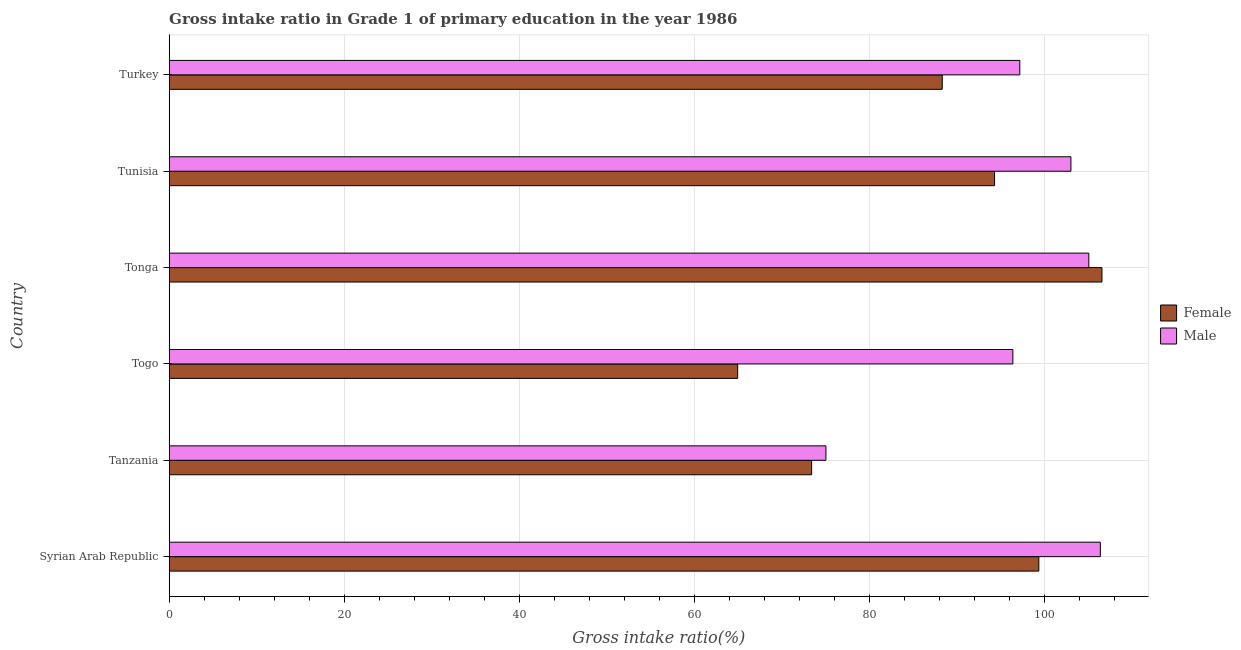How many different coloured bars are there?
Offer a terse response. 2. How many groups of bars are there?
Your answer should be compact. 6. Are the number of bars per tick equal to the number of legend labels?
Offer a very short reply. Yes. Are the number of bars on each tick of the Y-axis equal?
Provide a succinct answer. Yes. How many bars are there on the 6th tick from the bottom?
Offer a terse response. 2. What is the label of the 3rd group of bars from the top?
Keep it short and to the point. Tonga. What is the gross intake ratio(female) in Tunisia?
Keep it short and to the point. 94.3. Across all countries, what is the maximum gross intake ratio(female)?
Ensure brevity in your answer.  106.57. Across all countries, what is the minimum gross intake ratio(male)?
Ensure brevity in your answer.  75.04. In which country was the gross intake ratio(male) maximum?
Your answer should be compact. Syrian Arab Republic. In which country was the gross intake ratio(female) minimum?
Offer a very short reply. Togo. What is the total gross intake ratio(female) in the graph?
Make the answer very short. 526.92. What is the difference between the gross intake ratio(female) in Tonga and that in Tunisia?
Your answer should be very brief. 12.27. What is the difference between the gross intake ratio(female) in Tanzania and the gross intake ratio(male) in Tonga?
Provide a succinct answer. -31.67. What is the average gross intake ratio(male) per country?
Your answer should be very brief. 97.19. What is the difference between the gross intake ratio(female) and gross intake ratio(male) in Tunisia?
Offer a very short reply. -8.72. What is the ratio of the gross intake ratio(female) in Tonga to that in Turkey?
Make the answer very short. 1.21. Is the gross intake ratio(male) in Syrian Arab Republic less than that in Tanzania?
Your answer should be very brief. No. What is the difference between the highest and the second highest gross intake ratio(female)?
Provide a succinct answer. 7.21. What is the difference between the highest and the lowest gross intake ratio(male)?
Ensure brevity in your answer.  31.35. In how many countries, is the gross intake ratio(female) greater than the average gross intake ratio(female) taken over all countries?
Provide a short and direct response. 4. How many bars are there?
Make the answer very short. 12. Are all the bars in the graph horizontal?
Provide a succinct answer. Yes. How many countries are there in the graph?
Make the answer very short. 6. Does the graph contain any zero values?
Ensure brevity in your answer.  No. Does the graph contain grids?
Offer a very short reply. Yes. How are the legend labels stacked?
Your answer should be very brief. Vertical. What is the title of the graph?
Provide a succinct answer. Gross intake ratio in Grade 1 of primary education in the year 1986. What is the label or title of the X-axis?
Offer a terse response. Gross intake ratio(%). What is the Gross intake ratio(%) of Female in Syrian Arab Republic?
Ensure brevity in your answer.  99.36. What is the Gross intake ratio(%) of Male in Syrian Arab Republic?
Offer a very short reply. 106.39. What is the Gross intake ratio(%) in Female in Tanzania?
Your response must be concise. 73.4. What is the Gross intake ratio(%) in Male in Tanzania?
Make the answer very short. 75.04. What is the Gross intake ratio(%) of Female in Togo?
Your answer should be very brief. 64.95. What is the Gross intake ratio(%) of Male in Togo?
Keep it short and to the point. 96.4. What is the Gross intake ratio(%) in Female in Tonga?
Your response must be concise. 106.57. What is the Gross intake ratio(%) of Male in Tonga?
Keep it short and to the point. 105.08. What is the Gross intake ratio(%) of Female in Tunisia?
Make the answer very short. 94.3. What is the Gross intake ratio(%) in Male in Tunisia?
Ensure brevity in your answer.  103.03. What is the Gross intake ratio(%) of Female in Turkey?
Your response must be concise. 88.33. What is the Gross intake ratio(%) of Male in Turkey?
Your response must be concise. 97.19. Across all countries, what is the maximum Gross intake ratio(%) of Female?
Your answer should be compact. 106.57. Across all countries, what is the maximum Gross intake ratio(%) in Male?
Offer a very short reply. 106.39. Across all countries, what is the minimum Gross intake ratio(%) of Female?
Ensure brevity in your answer.  64.95. Across all countries, what is the minimum Gross intake ratio(%) in Male?
Provide a short and direct response. 75.04. What is the total Gross intake ratio(%) of Female in the graph?
Your answer should be very brief. 526.92. What is the total Gross intake ratio(%) of Male in the graph?
Keep it short and to the point. 583.12. What is the difference between the Gross intake ratio(%) of Female in Syrian Arab Republic and that in Tanzania?
Offer a terse response. 25.96. What is the difference between the Gross intake ratio(%) in Male in Syrian Arab Republic and that in Tanzania?
Offer a very short reply. 31.35. What is the difference between the Gross intake ratio(%) in Female in Syrian Arab Republic and that in Togo?
Offer a very short reply. 34.41. What is the difference between the Gross intake ratio(%) in Male in Syrian Arab Republic and that in Togo?
Ensure brevity in your answer.  9.99. What is the difference between the Gross intake ratio(%) in Female in Syrian Arab Republic and that in Tonga?
Offer a very short reply. -7.21. What is the difference between the Gross intake ratio(%) of Male in Syrian Arab Republic and that in Tonga?
Provide a short and direct response. 1.31. What is the difference between the Gross intake ratio(%) of Female in Syrian Arab Republic and that in Tunisia?
Give a very brief answer. 5.06. What is the difference between the Gross intake ratio(%) in Male in Syrian Arab Republic and that in Tunisia?
Ensure brevity in your answer.  3.36. What is the difference between the Gross intake ratio(%) in Female in Syrian Arab Republic and that in Turkey?
Provide a short and direct response. 11.04. What is the difference between the Gross intake ratio(%) of Male in Syrian Arab Republic and that in Turkey?
Your answer should be very brief. 9.2. What is the difference between the Gross intake ratio(%) in Female in Tanzania and that in Togo?
Ensure brevity in your answer.  8.45. What is the difference between the Gross intake ratio(%) of Male in Tanzania and that in Togo?
Keep it short and to the point. -21.36. What is the difference between the Gross intake ratio(%) in Female in Tanzania and that in Tonga?
Offer a terse response. -33.17. What is the difference between the Gross intake ratio(%) in Male in Tanzania and that in Tonga?
Give a very brief answer. -30.04. What is the difference between the Gross intake ratio(%) in Female in Tanzania and that in Tunisia?
Provide a succinct answer. -20.9. What is the difference between the Gross intake ratio(%) in Male in Tanzania and that in Tunisia?
Provide a succinct answer. -27.99. What is the difference between the Gross intake ratio(%) in Female in Tanzania and that in Turkey?
Your answer should be compact. -14.92. What is the difference between the Gross intake ratio(%) of Male in Tanzania and that in Turkey?
Give a very brief answer. -22.15. What is the difference between the Gross intake ratio(%) in Female in Togo and that in Tonga?
Offer a very short reply. -41.62. What is the difference between the Gross intake ratio(%) of Male in Togo and that in Tonga?
Ensure brevity in your answer.  -8.68. What is the difference between the Gross intake ratio(%) in Female in Togo and that in Tunisia?
Offer a terse response. -29.35. What is the difference between the Gross intake ratio(%) of Male in Togo and that in Tunisia?
Give a very brief answer. -6.63. What is the difference between the Gross intake ratio(%) in Female in Togo and that in Turkey?
Make the answer very short. -23.37. What is the difference between the Gross intake ratio(%) in Male in Togo and that in Turkey?
Your response must be concise. -0.79. What is the difference between the Gross intake ratio(%) in Female in Tonga and that in Tunisia?
Provide a succinct answer. 12.27. What is the difference between the Gross intake ratio(%) of Male in Tonga and that in Tunisia?
Give a very brief answer. 2.05. What is the difference between the Gross intake ratio(%) of Female in Tonga and that in Turkey?
Offer a terse response. 18.25. What is the difference between the Gross intake ratio(%) in Male in Tonga and that in Turkey?
Make the answer very short. 7.89. What is the difference between the Gross intake ratio(%) in Female in Tunisia and that in Turkey?
Make the answer very short. 5.98. What is the difference between the Gross intake ratio(%) of Male in Tunisia and that in Turkey?
Your answer should be very brief. 5.84. What is the difference between the Gross intake ratio(%) of Female in Syrian Arab Republic and the Gross intake ratio(%) of Male in Tanzania?
Make the answer very short. 24.33. What is the difference between the Gross intake ratio(%) of Female in Syrian Arab Republic and the Gross intake ratio(%) of Male in Togo?
Keep it short and to the point. 2.97. What is the difference between the Gross intake ratio(%) of Female in Syrian Arab Republic and the Gross intake ratio(%) of Male in Tonga?
Keep it short and to the point. -5.71. What is the difference between the Gross intake ratio(%) of Female in Syrian Arab Republic and the Gross intake ratio(%) of Male in Tunisia?
Keep it short and to the point. -3.67. What is the difference between the Gross intake ratio(%) in Female in Syrian Arab Republic and the Gross intake ratio(%) in Male in Turkey?
Offer a terse response. 2.18. What is the difference between the Gross intake ratio(%) in Female in Tanzania and the Gross intake ratio(%) in Male in Togo?
Offer a very short reply. -22.99. What is the difference between the Gross intake ratio(%) in Female in Tanzania and the Gross intake ratio(%) in Male in Tonga?
Offer a very short reply. -31.67. What is the difference between the Gross intake ratio(%) in Female in Tanzania and the Gross intake ratio(%) in Male in Tunisia?
Your answer should be very brief. -29.63. What is the difference between the Gross intake ratio(%) of Female in Tanzania and the Gross intake ratio(%) of Male in Turkey?
Your response must be concise. -23.78. What is the difference between the Gross intake ratio(%) of Female in Togo and the Gross intake ratio(%) of Male in Tonga?
Your answer should be very brief. -40.12. What is the difference between the Gross intake ratio(%) of Female in Togo and the Gross intake ratio(%) of Male in Tunisia?
Keep it short and to the point. -38.08. What is the difference between the Gross intake ratio(%) in Female in Togo and the Gross intake ratio(%) in Male in Turkey?
Your response must be concise. -32.24. What is the difference between the Gross intake ratio(%) in Female in Tonga and the Gross intake ratio(%) in Male in Tunisia?
Your answer should be compact. 3.55. What is the difference between the Gross intake ratio(%) in Female in Tonga and the Gross intake ratio(%) in Male in Turkey?
Make the answer very short. 9.39. What is the difference between the Gross intake ratio(%) of Female in Tunisia and the Gross intake ratio(%) of Male in Turkey?
Give a very brief answer. -2.88. What is the average Gross intake ratio(%) in Female per country?
Make the answer very short. 87.82. What is the average Gross intake ratio(%) of Male per country?
Make the answer very short. 97.19. What is the difference between the Gross intake ratio(%) of Female and Gross intake ratio(%) of Male in Syrian Arab Republic?
Provide a succinct answer. -7.03. What is the difference between the Gross intake ratio(%) of Female and Gross intake ratio(%) of Male in Tanzania?
Provide a succinct answer. -1.63. What is the difference between the Gross intake ratio(%) in Female and Gross intake ratio(%) in Male in Togo?
Ensure brevity in your answer.  -31.44. What is the difference between the Gross intake ratio(%) of Female and Gross intake ratio(%) of Male in Tonga?
Give a very brief answer. 1.5. What is the difference between the Gross intake ratio(%) of Female and Gross intake ratio(%) of Male in Tunisia?
Give a very brief answer. -8.72. What is the difference between the Gross intake ratio(%) of Female and Gross intake ratio(%) of Male in Turkey?
Offer a terse response. -8.86. What is the ratio of the Gross intake ratio(%) of Female in Syrian Arab Republic to that in Tanzania?
Offer a terse response. 1.35. What is the ratio of the Gross intake ratio(%) of Male in Syrian Arab Republic to that in Tanzania?
Keep it short and to the point. 1.42. What is the ratio of the Gross intake ratio(%) in Female in Syrian Arab Republic to that in Togo?
Your answer should be compact. 1.53. What is the ratio of the Gross intake ratio(%) of Male in Syrian Arab Republic to that in Togo?
Offer a very short reply. 1.1. What is the ratio of the Gross intake ratio(%) in Female in Syrian Arab Republic to that in Tonga?
Provide a short and direct response. 0.93. What is the ratio of the Gross intake ratio(%) of Male in Syrian Arab Republic to that in Tonga?
Make the answer very short. 1.01. What is the ratio of the Gross intake ratio(%) of Female in Syrian Arab Republic to that in Tunisia?
Make the answer very short. 1.05. What is the ratio of the Gross intake ratio(%) in Male in Syrian Arab Republic to that in Tunisia?
Keep it short and to the point. 1.03. What is the ratio of the Gross intake ratio(%) in Female in Syrian Arab Republic to that in Turkey?
Provide a short and direct response. 1.12. What is the ratio of the Gross intake ratio(%) in Male in Syrian Arab Republic to that in Turkey?
Give a very brief answer. 1.09. What is the ratio of the Gross intake ratio(%) of Female in Tanzania to that in Togo?
Give a very brief answer. 1.13. What is the ratio of the Gross intake ratio(%) in Male in Tanzania to that in Togo?
Give a very brief answer. 0.78. What is the ratio of the Gross intake ratio(%) in Female in Tanzania to that in Tonga?
Your response must be concise. 0.69. What is the ratio of the Gross intake ratio(%) in Male in Tanzania to that in Tonga?
Give a very brief answer. 0.71. What is the ratio of the Gross intake ratio(%) in Female in Tanzania to that in Tunisia?
Provide a succinct answer. 0.78. What is the ratio of the Gross intake ratio(%) in Male in Tanzania to that in Tunisia?
Offer a terse response. 0.73. What is the ratio of the Gross intake ratio(%) in Female in Tanzania to that in Turkey?
Give a very brief answer. 0.83. What is the ratio of the Gross intake ratio(%) of Male in Tanzania to that in Turkey?
Your answer should be compact. 0.77. What is the ratio of the Gross intake ratio(%) of Female in Togo to that in Tonga?
Give a very brief answer. 0.61. What is the ratio of the Gross intake ratio(%) of Male in Togo to that in Tonga?
Make the answer very short. 0.92. What is the ratio of the Gross intake ratio(%) of Female in Togo to that in Tunisia?
Make the answer very short. 0.69. What is the ratio of the Gross intake ratio(%) of Male in Togo to that in Tunisia?
Your answer should be compact. 0.94. What is the ratio of the Gross intake ratio(%) of Female in Togo to that in Turkey?
Make the answer very short. 0.74. What is the ratio of the Gross intake ratio(%) of Male in Togo to that in Turkey?
Ensure brevity in your answer.  0.99. What is the ratio of the Gross intake ratio(%) in Female in Tonga to that in Tunisia?
Give a very brief answer. 1.13. What is the ratio of the Gross intake ratio(%) of Male in Tonga to that in Tunisia?
Offer a very short reply. 1.02. What is the ratio of the Gross intake ratio(%) in Female in Tonga to that in Turkey?
Give a very brief answer. 1.21. What is the ratio of the Gross intake ratio(%) of Male in Tonga to that in Turkey?
Offer a very short reply. 1.08. What is the ratio of the Gross intake ratio(%) in Female in Tunisia to that in Turkey?
Your response must be concise. 1.07. What is the ratio of the Gross intake ratio(%) in Male in Tunisia to that in Turkey?
Provide a short and direct response. 1.06. What is the difference between the highest and the second highest Gross intake ratio(%) in Female?
Give a very brief answer. 7.21. What is the difference between the highest and the second highest Gross intake ratio(%) in Male?
Give a very brief answer. 1.31. What is the difference between the highest and the lowest Gross intake ratio(%) in Female?
Your response must be concise. 41.62. What is the difference between the highest and the lowest Gross intake ratio(%) in Male?
Your answer should be very brief. 31.35. 